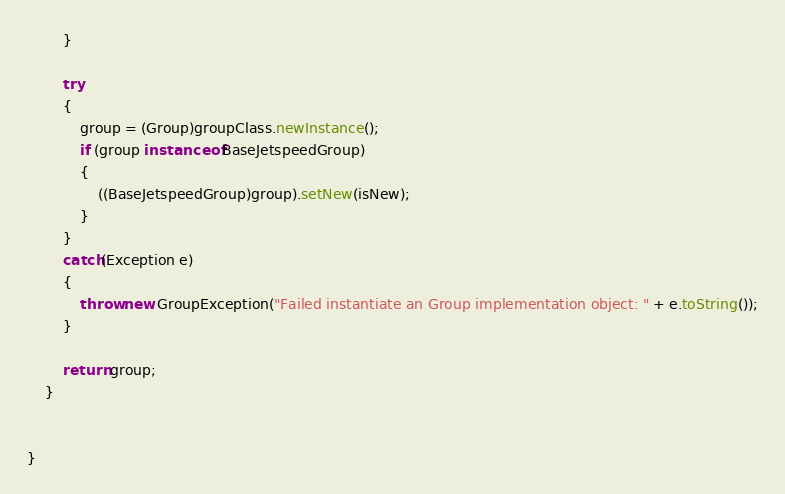<code> <loc_0><loc_0><loc_500><loc_500><_Java_>        }

        try
        {
            group = (Group)groupClass.newInstance();
            if (group instanceof BaseJetspeedGroup)
            {
                ((BaseJetspeedGroup)group).setNew(isNew);
            }            
        }
        catch(Exception e)
        {
            throw new GroupException("Failed instantiate an Group implementation object: " + e.toString());
        }

        return group;
    }
    

}



</code> 